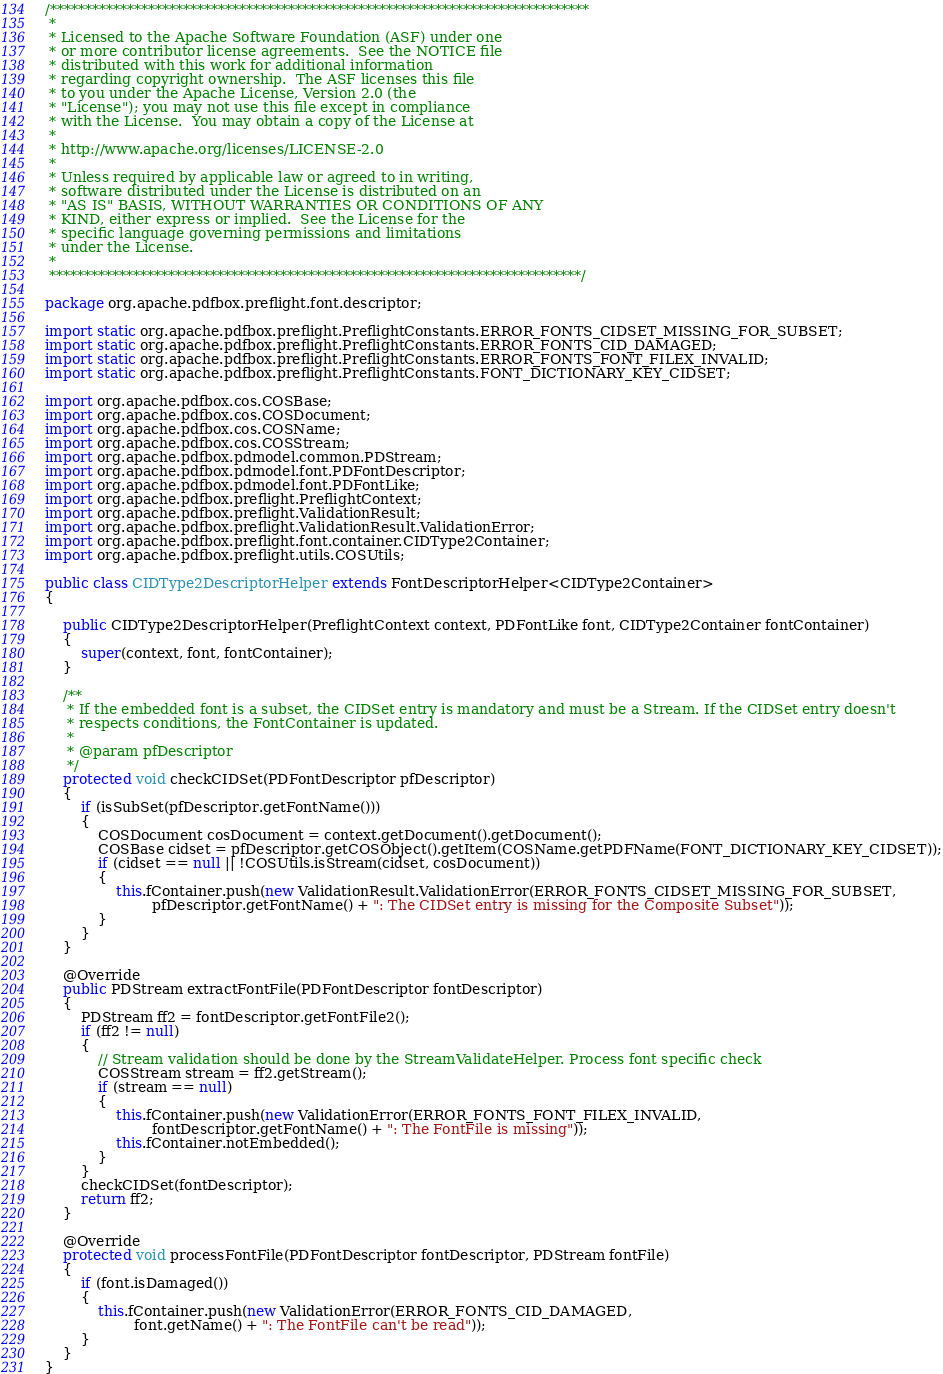Convert code to text. <code><loc_0><loc_0><loc_500><loc_500><_Java_>/*****************************************************************************
 * 
 * Licensed to the Apache Software Foundation (ASF) under one
 * or more contributor license agreements.  See the NOTICE file
 * distributed with this work for additional information
 * regarding copyright ownership.  The ASF licenses this file
 * to you under the Apache License, Version 2.0 (the
 * "License"); you may not use this file except in compliance
 * with the License.  You may obtain a copy of the License at
 * 
 * http://www.apache.org/licenses/LICENSE-2.0
 * 
 * Unless required by applicable law or agreed to in writing,
 * software distributed under the License is distributed on an
 * "AS IS" BASIS, WITHOUT WARRANTIES OR CONDITIONS OF ANY
 * KIND, either express or implied.  See the License for the
 * specific language governing permissions and limitations
 * under the License.
 * 
 ****************************************************************************/

package org.apache.pdfbox.preflight.font.descriptor;

import static org.apache.pdfbox.preflight.PreflightConstants.ERROR_FONTS_CIDSET_MISSING_FOR_SUBSET;
import static org.apache.pdfbox.preflight.PreflightConstants.ERROR_FONTS_CID_DAMAGED;
import static org.apache.pdfbox.preflight.PreflightConstants.ERROR_FONTS_FONT_FILEX_INVALID;
import static org.apache.pdfbox.preflight.PreflightConstants.FONT_DICTIONARY_KEY_CIDSET;

import org.apache.pdfbox.cos.COSBase;
import org.apache.pdfbox.cos.COSDocument;
import org.apache.pdfbox.cos.COSName;
import org.apache.pdfbox.cos.COSStream;
import org.apache.pdfbox.pdmodel.common.PDStream;
import org.apache.pdfbox.pdmodel.font.PDFontDescriptor;
import org.apache.pdfbox.pdmodel.font.PDFontLike;
import org.apache.pdfbox.preflight.PreflightContext;
import org.apache.pdfbox.preflight.ValidationResult;
import org.apache.pdfbox.preflight.ValidationResult.ValidationError;
import org.apache.pdfbox.preflight.font.container.CIDType2Container;
import org.apache.pdfbox.preflight.utils.COSUtils;

public class CIDType2DescriptorHelper extends FontDescriptorHelper<CIDType2Container>
{

    public CIDType2DescriptorHelper(PreflightContext context, PDFontLike font, CIDType2Container fontContainer)
    {
        super(context, font, fontContainer);
    }

    /**
     * If the embedded font is a subset, the CIDSet entry is mandatory and must be a Stream. If the CIDSet entry doesn't
     * respects conditions, the FontContainer is updated.
     * 
     * @param pfDescriptor
     */
    protected void checkCIDSet(PDFontDescriptor pfDescriptor)
    {
        if (isSubSet(pfDescriptor.getFontName()))
        {
            COSDocument cosDocument = context.getDocument().getDocument();
            COSBase cidset = pfDescriptor.getCOSObject().getItem(COSName.getPDFName(FONT_DICTIONARY_KEY_CIDSET));
            if (cidset == null || !COSUtils.isStream(cidset, cosDocument))
            {
                this.fContainer.push(new ValidationResult.ValidationError(ERROR_FONTS_CIDSET_MISSING_FOR_SUBSET,
                        pfDescriptor.getFontName() + ": The CIDSet entry is missing for the Composite Subset"));
            }
        }
    }

    @Override
    public PDStream extractFontFile(PDFontDescriptor fontDescriptor)
    {
        PDStream ff2 = fontDescriptor.getFontFile2();
        if (ff2 != null)
        {
            // Stream validation should be done by the StreamValidateHelper. Process font specific check
            COSStream stream = ff2.getStream();
            if (stream == null)
            {
                this.fContainer.push(new ValidationError(ERROR_FONTS_FONT_FILEX_INVALID, 
                        fontDescriptor.getFontName() + ": The FontFile is missing"));
                this.fContainer.notEmbedded();
            }
        }
        checkCIDSet(fontDescriptor);
        return ff2;
    }

    @Override
    protected void processFontFile(PDFontDescriptor fontDescriptor, PDStream fontFile)
    {
        if (font.isDamaged())
        {
            this.fContainer.push(new ValidationError(ERROR_FONTS_CID_DAMAGED, 
                    font.getName() + ": The FontFile can't be read"));
        }
    }
}
</code> 